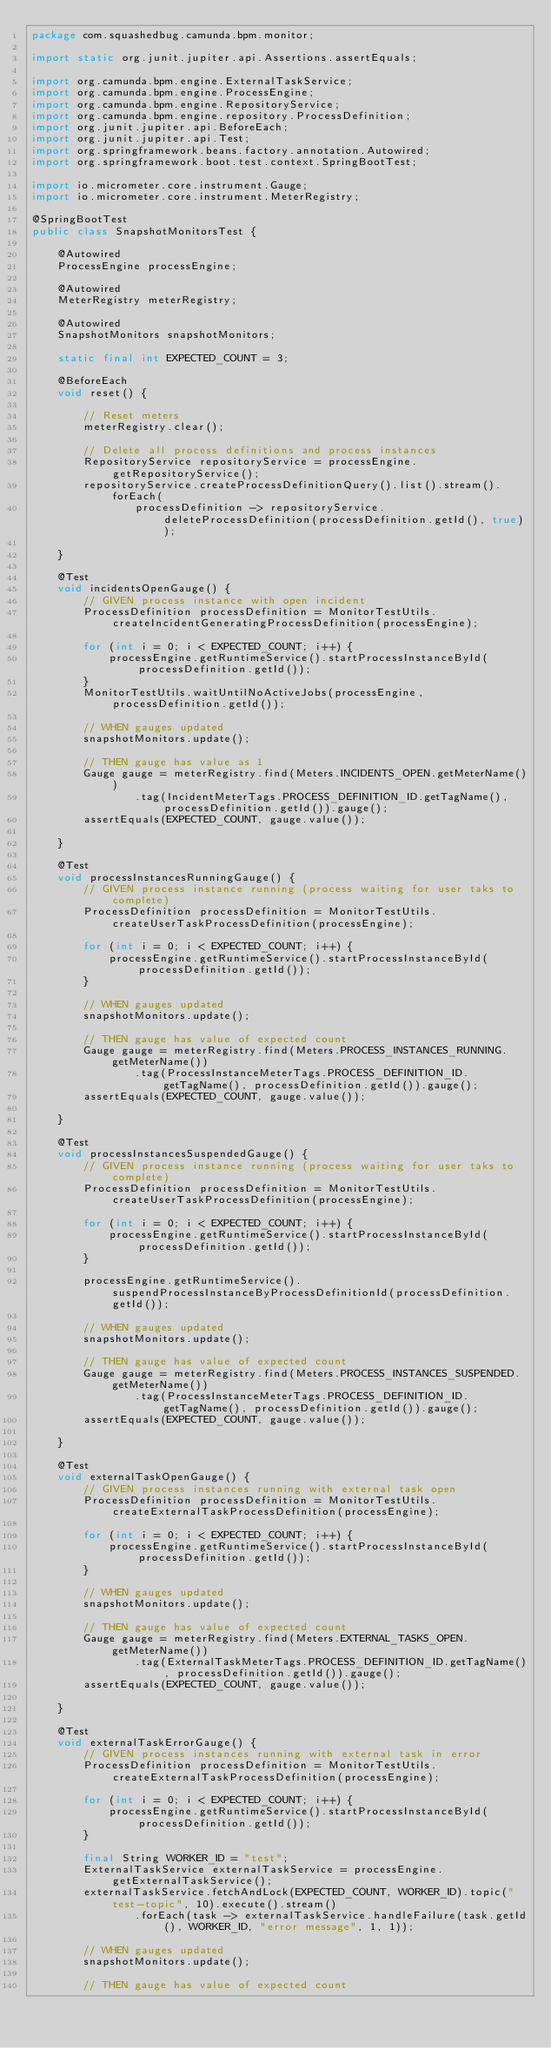<code> <loc_0><loc_0><loc_500><loc_500><_Java_>package com.squashedbug.camunda.bpm.monitor;

import static org.junit.jupiter.api.Assertions.assertEquals;

import org.camunda.bpm.engine.ExternalTaskService;
import org.camunda.bpm.engine.ProcessEngine;
import org.camunda.bpm.engine.RepositoryService;
import org.camunda.bpm.engine.repository.ProcessDefinition;
import org.junit.jupiter.api.BeforeEach;
import org.junit.jupiter.api.Test;
import org.springframework.beans.factory.annotation.Autowired;
import org.springframework.boot.test.context.SpringBootTest;

import io.micrometer.core.instrument.Gauge;
import io.micrometer.core.instrument.MeterRegistry;

@SpringBootTest
public class SnapshotMonitorsTest {

    @Autowired
    ProcessEngine processEngine;

    @Autowired
    MeterRegistry meterRegistry;

    @Autowired
    SnapshotMonitors snapshotMonitors;

    static final int EXPECTED_COUNT = 3;

    @BeforeEach
    void reset() {

        // Reset meters
        meterRegistry.clear();

        // Delete all process definitions and process instances
        RepositoryService repositoryService = processEngine.getRepositoryService();
        repositoryService.createProcessDefinitionQuery().list().stream().forEach(
                processDefinition -> repositoryService.deleteProcessDefinition(processDefinition.getId(), true));

    }

    @Test
    void incidentsOpenGauge() {
        // GIVEN process instance with open incident
        ProcessDefinition processDefinition = MonitorTestUtils.createIncidentGeneratingProcessDefinition(processEngine);

        for (int i = 0; i < EXPECTED_COUNT; i++) {
            processEngine.getRuntimeService().startProcessInstanceById(processDefinition.getId());
        }
        MonitorTestUtils.waitUntilNoActiveJobs(processEngine, processDefinition.getId());

        // WHEN gauges updated
        snapshotMonitors.update();

        // THEN gauge has value as 1
        Gauge gauge = meterRegistry.find(Meters.INCIDENTS_OPEN.getMeterName())
                .tag(IncidentMeterTags.PROCESS_DEFINITION_ID.getTagName(), processDefinition.getId()).gauge();
        assertEquals(EXPECTED_COUNT, gauge.value());

    }

    @Test
    void processInstancesRunningGauge() {
        // GIVEN process instance running (process waiting for user taks to complete)
        ProcessDefinition processDefinition = MonitorTestUtils.createUserTaskProcessDefinition(processEngine);

        for (int i = 0; i < EXPECTED_COUNT; i++) {
            processEngine.getRuntimeService().startProcessInstanceById(processDefinition.getId());
        }

        // WHEN gauges updated
        snapshotMonitors.update();

        // THEN gauge has value of expected count
        Gauge gauge = meterRegistry.find(Meters.PROCESS_INSTANCES_RUNNING.getMeterName())
                .tag(ProcessInstanceMeterTags.PROCESS_DEFINITION_ID.getTagName(), processDefinition.getId()).gauge();
        assertEquals(EXPECTED_COUNT, gauge.value());

    }

    @Test
    void processInstancesSuspendedGauge() {
        // GIVEN process instance running (process waiting for user taks to complete)
        ProcessDefinition processDefinition = MonitorTestUtils.createUserTaskProcessDefinition(processEngine);

        for (int i = 0; i < EXPECTED_COUNT; i++) {
            processEngine.getRuntimeService().startProcessInstanceById(processDefinition.getId());
        }

        processEngine.getRuntimeService().suspendProcessInstanceByProcessDefinitionId(processDefinition.getId());

        // WHEN gauges updated
        snapshotMonitors.update();

        // THEN gauge has value of expected count
        Gauge gauge = meterRegistry.find(Meters.PROCESS_INSTANCES_SUSPENDED.getMeterName())
                .tag(ProcessInstanceMeterTags.PROCESS_DEFINITION_ID.getTagName(), processDefinition.getId()).gauge();
        assertEquals(EXPECTED_COUNT, gauge.value());

    }

    @Test
    void externalTaskOpenGauge() {
        // GIVEN process instances running with external task open
        ProcessDefinition processDefinition = MonitorTestUtils.createExternalTaskProcessDefinition(processEngine);

        for (int i = 0; i < EXPECTED_COUNT; i++) {
            processEngine.getRuntimeService().startProcessInstanceById(processDefinition.getId());
        }

        // WHEN gauges updated
        snapshotMonitors.update();

        // THEN gauge has value of expected count
        Gauge gauge = meterRegistry.find(Meters.EXTERNAL_TASKS_OPEN.getMeterName())
                .tag(ExternalTaskMeterTags.PROCESS_DEFINITION_ID.getTagName(), processDefinition.getId()).gauge();
        assertEquals(EXPECTED_COUNT, gauge.value());

    }

    @Test
    void externalTaskErrorGauge() {
        // GIVEN process instances running with external task in error
        ProcessDefinition processDefinition = MonitorTestUtils.createExternalTaskProcessDefinition(processEngine);

        for (int i = 0; i < EXPECTED_COUNT; i++) {
            processEngine.getRuntimeService().startProcessInstanceById(processDefinition.getId());
        }

        final String WORKER_ID = "test";
        ExternalTaskService externalTaskService = processEngine.getExternalTaskService();
        externalTaskService.fetchAndLock(EXPECTED_COUNT, WORKER_ID).topic("test-topic", 10).execute().stream()
                .forEach(task -> externalTaskService.handleFailure(task.getId(), WORKER_ID, "error message", 1, 1));

        // WHEN gauges updated
        snapshotMonitors.update();

        // THEN gauge has value of expected count</code> 